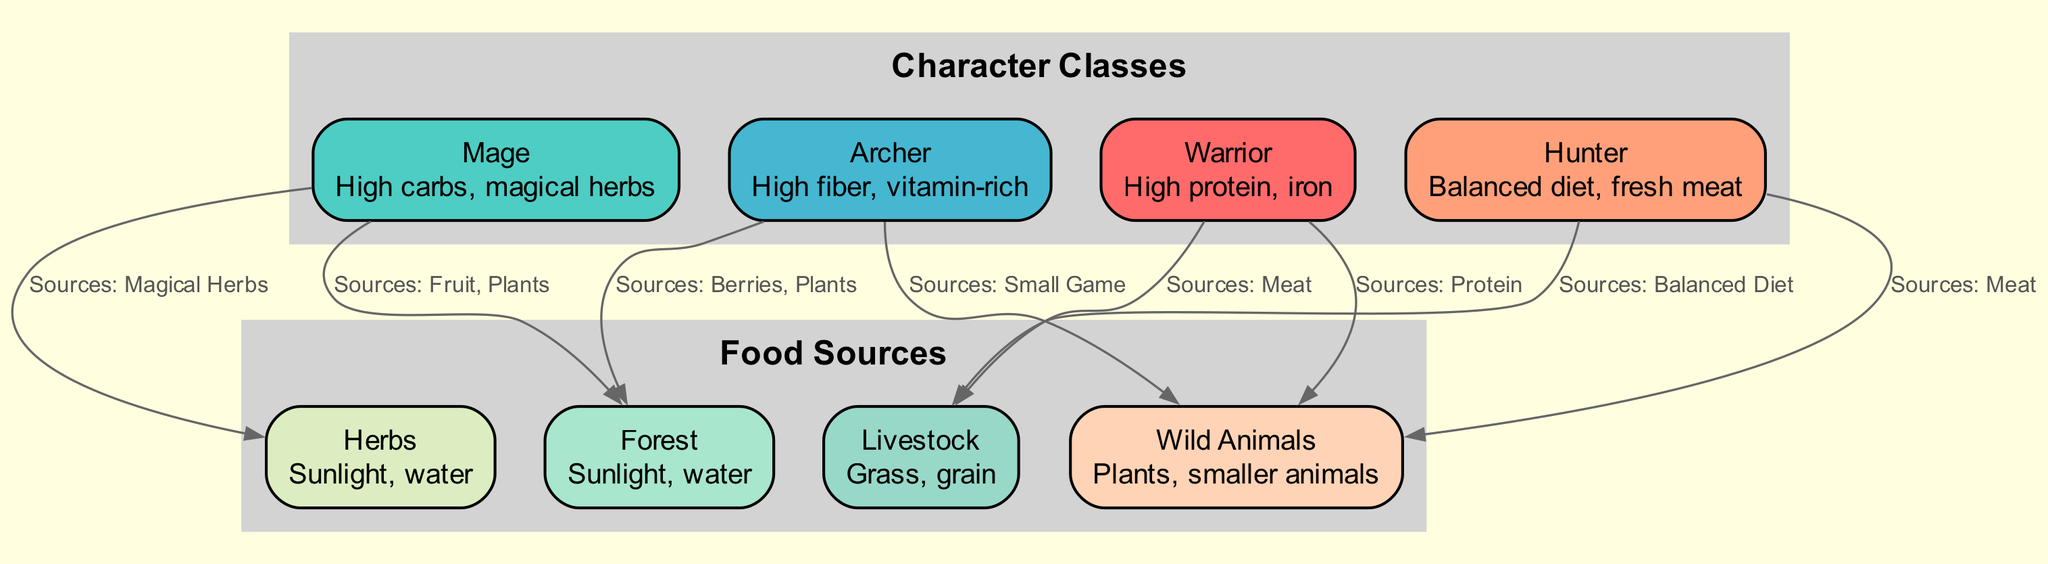What are the dietary needs of the Warrior? The diagram shows that the Warrior has dietary needs for "High protein, iron." This information is clearly stated in the node for the Warrior.
Answer: High protein, iron How many edges connect to the Mage? By examining the edges originating from the Mage node, we see that there are two edges: one connecting to Herbs and the other to Forest. Thus, there are two edges.
Answer: 2 Which food source do Archers utilize for sourcing vitamin-rich food? It is indicated in the diagram that Archers source vitamin-rich food from the Forest. The connection from the Archer to the Forest node represents this sourcing.
Answer: Forest What is the primary food source for the Hunter? According to the edges related to the Hunter, the primary food source is Wild Animals since it is specifically mentioned that the Hunter sources meat from them.
Answer: Wild Animals How many character classes are represented in the diagram? The diagram showcases four character classes: Warrior, Mage, Archer, and Hunter. By counting these nodes, we confirm there are four character classes.
Answer: 4 From which food source do Mages obtain magical herbs? The diagram indicates that Mages obtain magical herbs from the Herbs node. This relationship is established through the directed edge from Mage to Herbs.
Answer: Herbs Which character class sources from both Wild Animals and Livestock? Observing the edges, we find that the Hunter class sources food from both Wild Animals and Livestock, as indicated by the connections in the diagram.
Answer: Hunter What is the dietary requirement for Wild Animals? The dietary needs stated in the Wild Animals node are "Plants, smaller animals." This is explicitly noted in the diagram.
Answer: Plants, smaller animals Which character class has the most diverse food sources listed? The Hunter class sources food from both Wild Animals and Livestock, showing more diversity compared to others. This is seen in the multiple edges connected to the Hunter node.
Answer: Hunter 